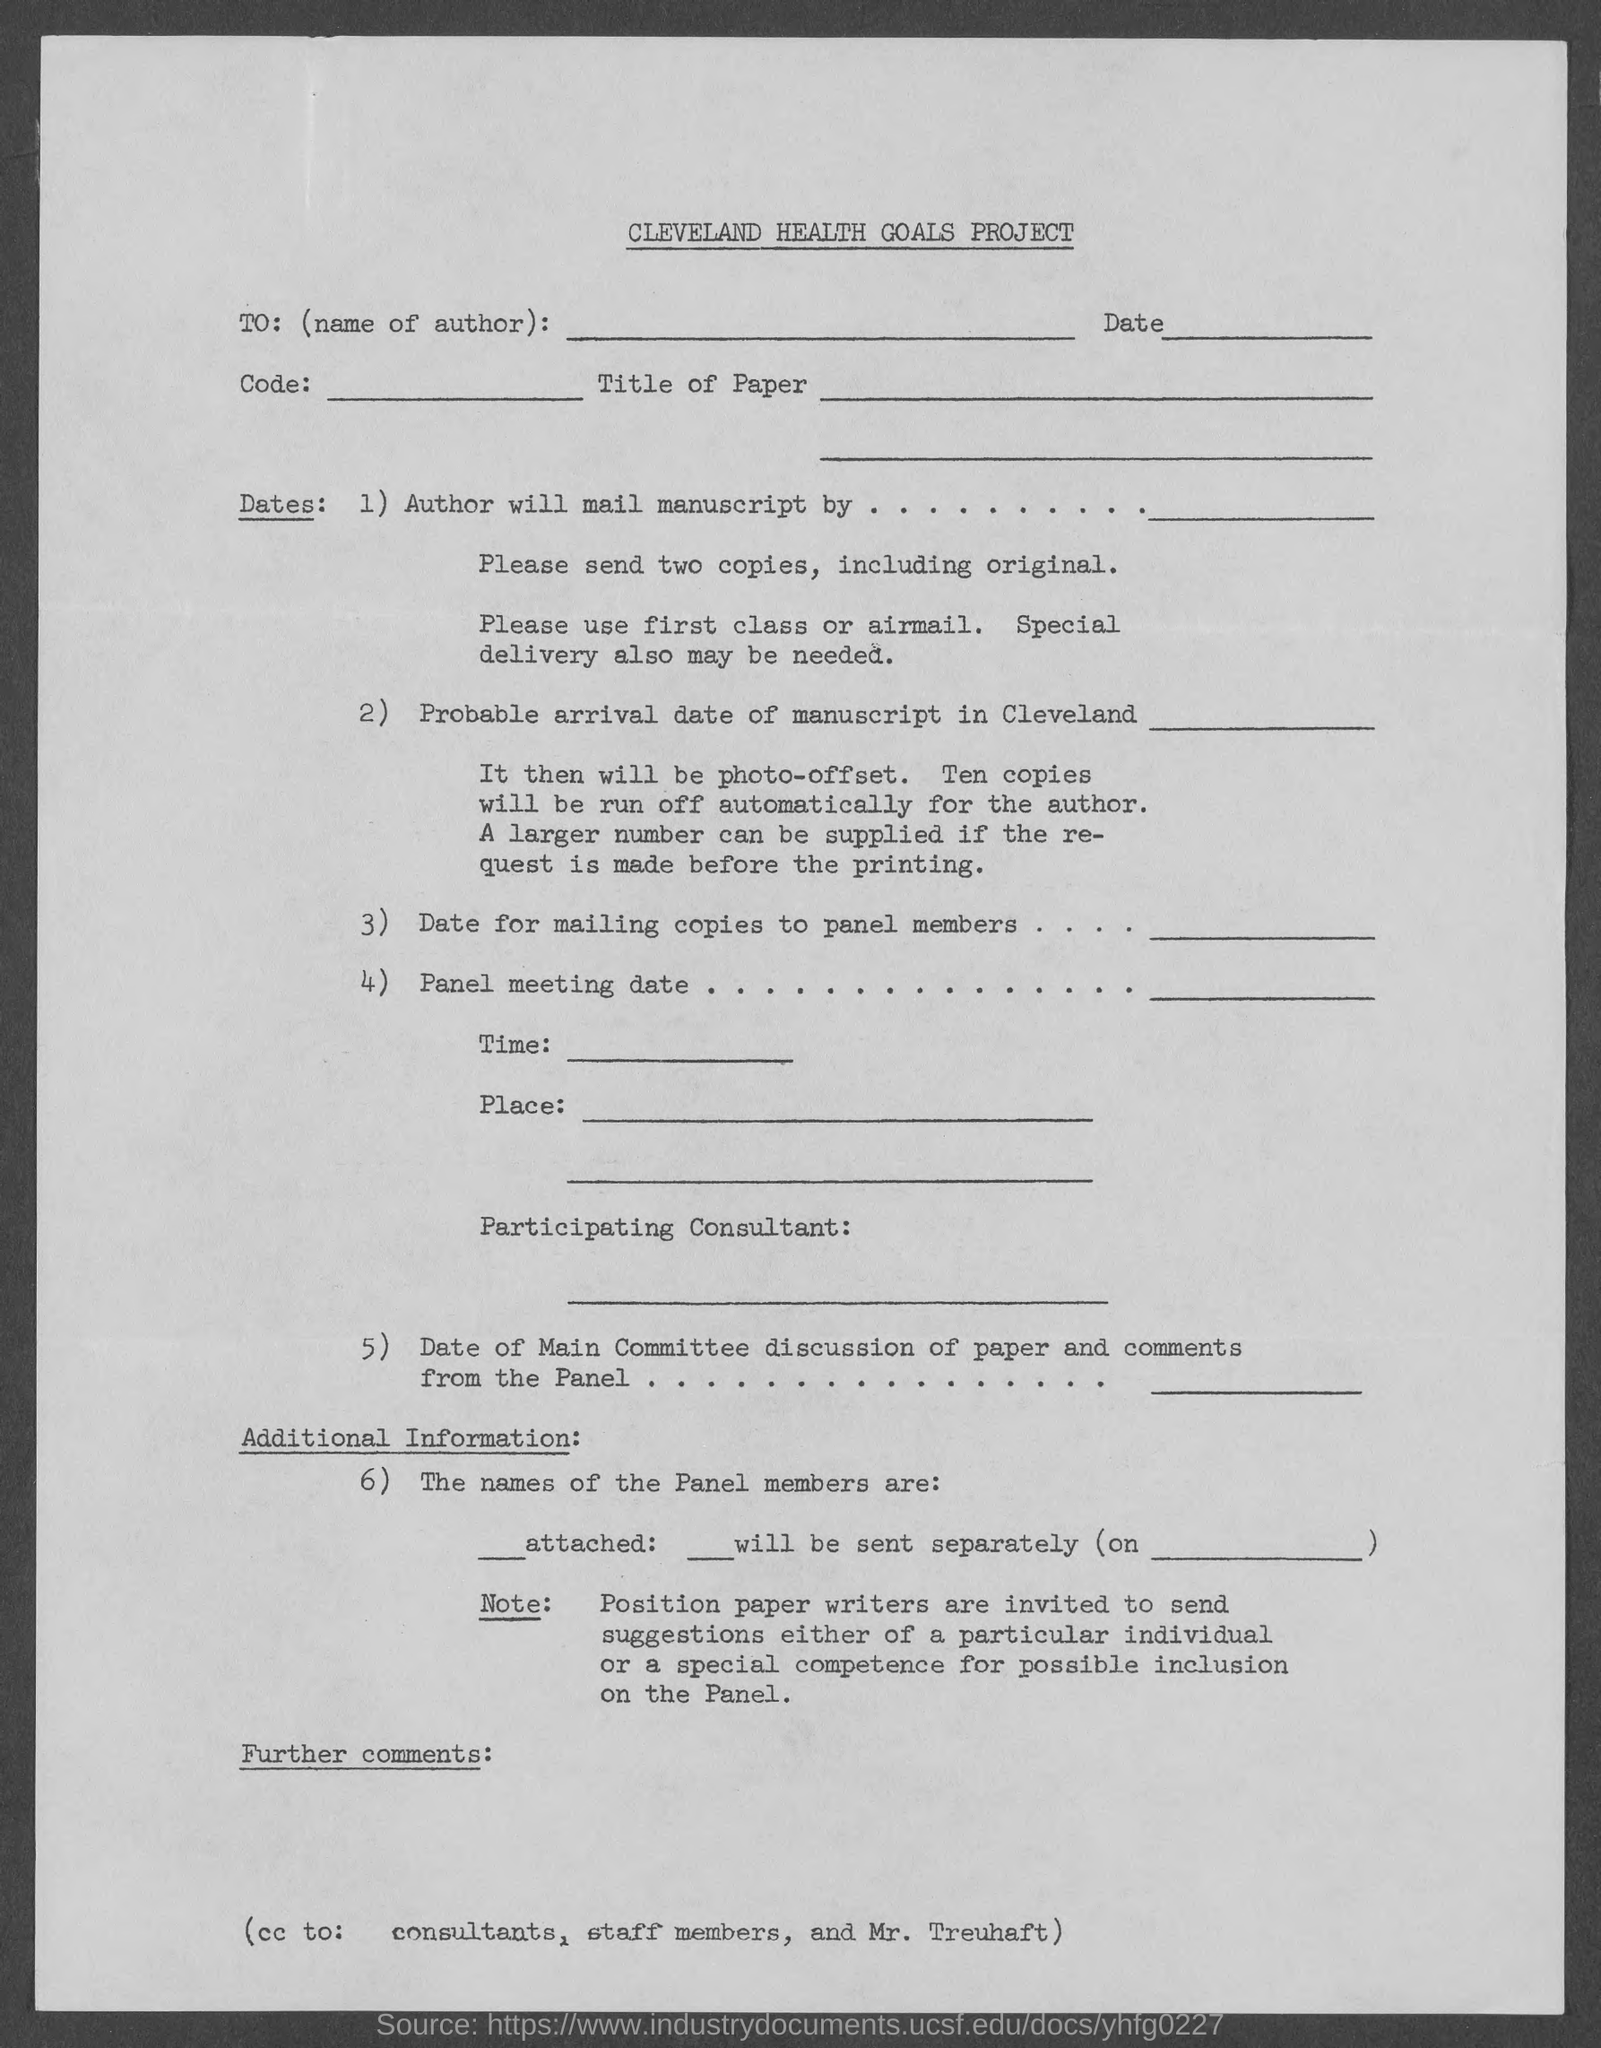What is the heading of the document?
Keep it short and to the point. CLEVELAND HEALTH GOALS PROJECT. What does "TO" in top of the document represents?
Offer a very short reply. Name of Author. 